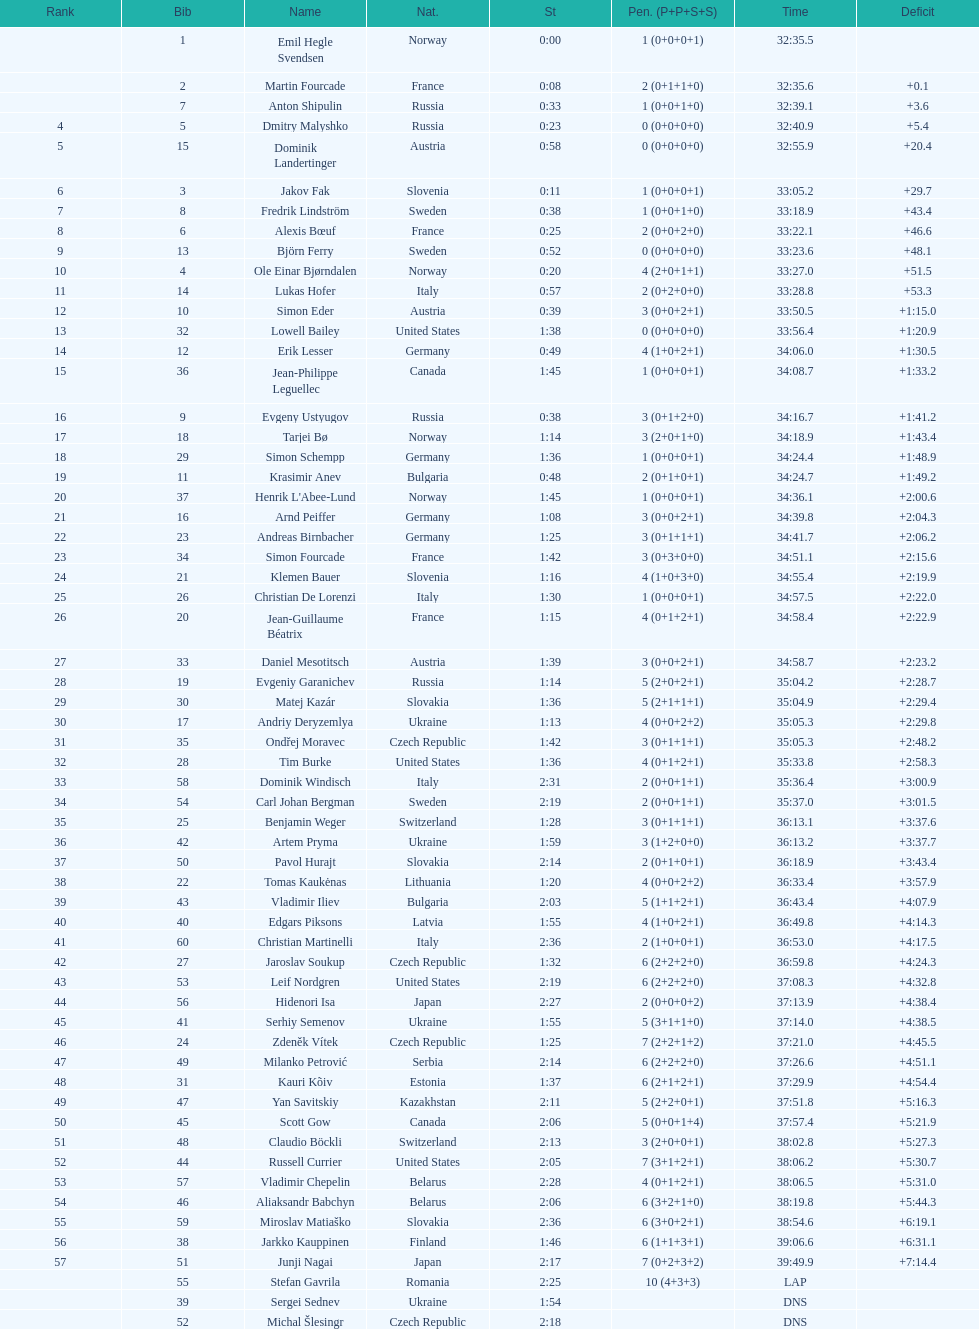How many took at least 35:00 to finish? 30. 